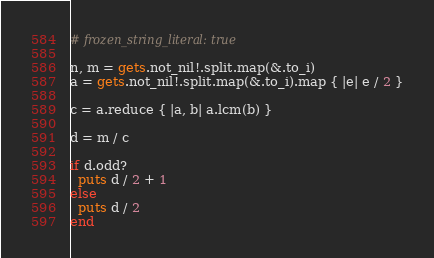<code> <loc_0><loc_0><loc_500><loc_500><_Crystal_># frozen_string_literal: true

n, m = gets.not_nil!.split.map(&.to_i)
a = gets.not_nil!.split.map(&.to_i).map { |e| e / 2 }

c = a.reduce { |a, b| a.lcm(b) }

d = m / c

if d.odd?
  puts d / 2 + 1
else
  puts d / 2
end
</code> 